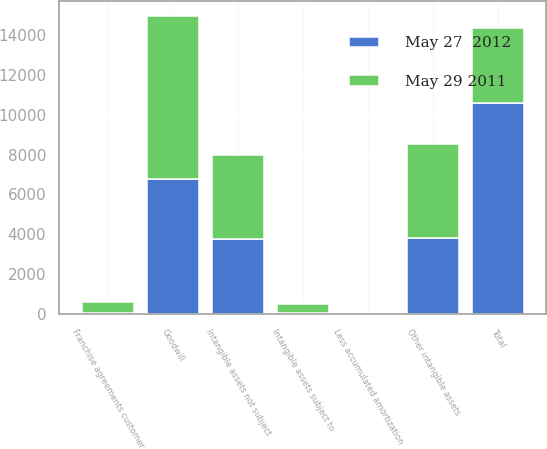<chart> <loc_0><loc_0><loc_500><loc_500><stacked_bar_chart><ecel><fcel>Goodwill<fcel>Intangible assets not subject<fcel>Franchise agreements customer<fcel>Less accumulated amortization<fcel>Intangible assets subject to<fcel>Other intangible assets<fcel>Total<nl><fcel>May 29 2011<fcel>8182.5<fcel>4217.1<fcel>544.7<fcel>56.9<fcel>487.8<fcel>4704.9<fcel>3771.7<nl><fcel>May 27  2012<fcel>6750.8<fcel>3771.7<fcel>69.2<fcel>27.6<fcel>41.6<fcel>3813.3<fcel>10564.1<nl></chart> 